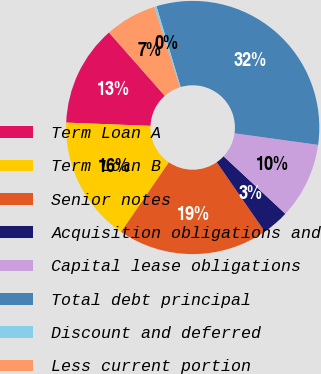Convert chart. <chart><loc_0><loc_0><loc_500><loc_500><pie_chart><fcel>Term Loan A<fcel>Term Loan B<fcel>Senior notes<fcel>Acquisition obligations and<fcel>Capital lease obligations<fcel>Total debt principal<fcel>Discount and deferred<fcel>Less current portion<nl><fcel>12.89%<fcel>16.05%<fcel>19.2%<fcel>3.43%<fcel>9.74%<fcel>31.82%<fcel>0.28%<fcel>6.59%<nl></chart> 